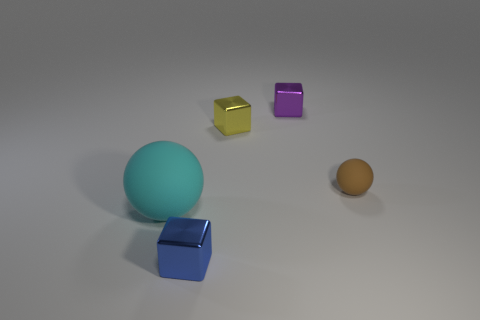There is a sphere to the left of the tiny object in front of the big matte ball; is there a blue metallic thing right of it?
Your response must be concise. Yes. Is there a purple metal block?
Provide a short and direct response. Yes. Is the number of tiny brown spheres that are behind the small rubber sphere greater than the number of big rubber objects that are in front of the blue shiny cube?
Make the answer very short. No. There is a blue thing that is made of the same material as the purple thing; what size is it?
Keep it short and to the point. Small. What is the size of the thing on the left side of the thing that is in front of the rubber ball on the left side of the blue thing?
Your response must be concise. Large. What is the color of the large sphere that is to the left of the yellow object?
Ensure brevity in your answer.  Cyan. Is the number of large cyan spheres that are in front of the small yellow object greater than the number of brown metal blocks?
Give a very brief answer. Yes. Does the tiny thing that is in front of the tiny rubber thing have the same shape as the tiny rubber thing?
Offer a terse response. No. What number of yellow things are either shiny blocks or rubber balls?
Keep it short and to the point. 1. Are there more balls than small brown balls?
Offer a terse response. Yes. 